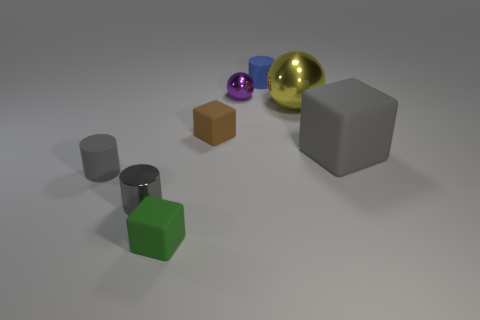Is there anything else that is made of the same material as the tiny green object?
Make the answer very short. Yes. Is the small brown rubber thing the same shape as the large yellow object?
Offer a very short reply. No. There is a sphere that is the same size as the gray matte cylinder; what is its color?
Your answer should be very brief. Purple. Is the number of small blue rubber cylinders that are right of the blue rubber object the same as the number of small green cubes?
Offer a terse response. No. The rubber thing that is both on the right side of the purple metallic object and in front of the tiny purple metal sphere has what shape?
Offer a very short reply. Cube. Do the blue cylinder and the yellow ball have the same size?
Your answer should be compact. No. Are there any purple spheres made of the same material as the brown cube?
Your answer should be very brief. No. What size is the rubber cylinder that is the same color as the metallic cylinder?
Ensure brevity in your answer.  Small. What number of tiny objects are both behind the gray shiny thing and to the left of the green block?
Provide a short and direct response. 1. There is a ball to the right of the blue rubber thing; what is its material?
Provide a short and direct response. Metal. 